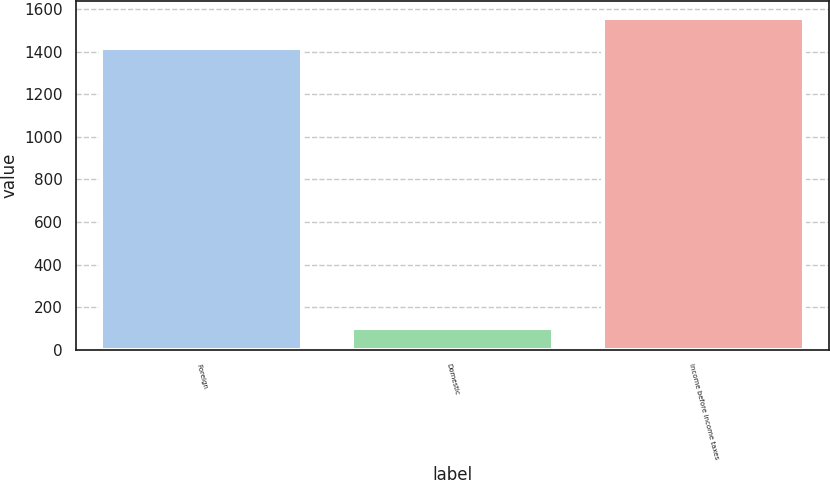<chart> <loc_0><loc_0><loc_500><loc_500><bar_chart><fcel>Foreign<fcel>Domestic<fcel>Income before income taxes<nl><fcel>1418<fcel>102<fcel>1559.8<nl></chart> 